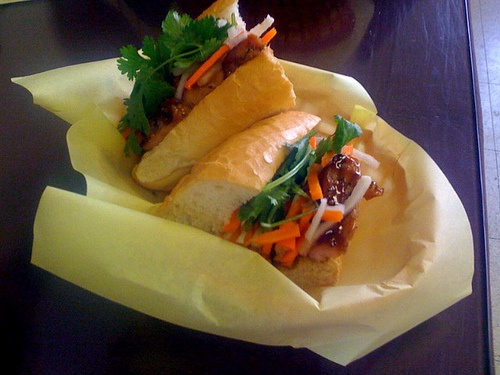Describe the objects in this image and their specific colors. I can see sandwich in olive, maroon, black, and tan tones, sandwich in olive, black, maroon, and darkgreen tones, carrot in olive, brown, maroon, and black tones, carrot in olive, brown, red, and maroon tones, and carrot in olive, brown, maroon, and red tones in this image. 